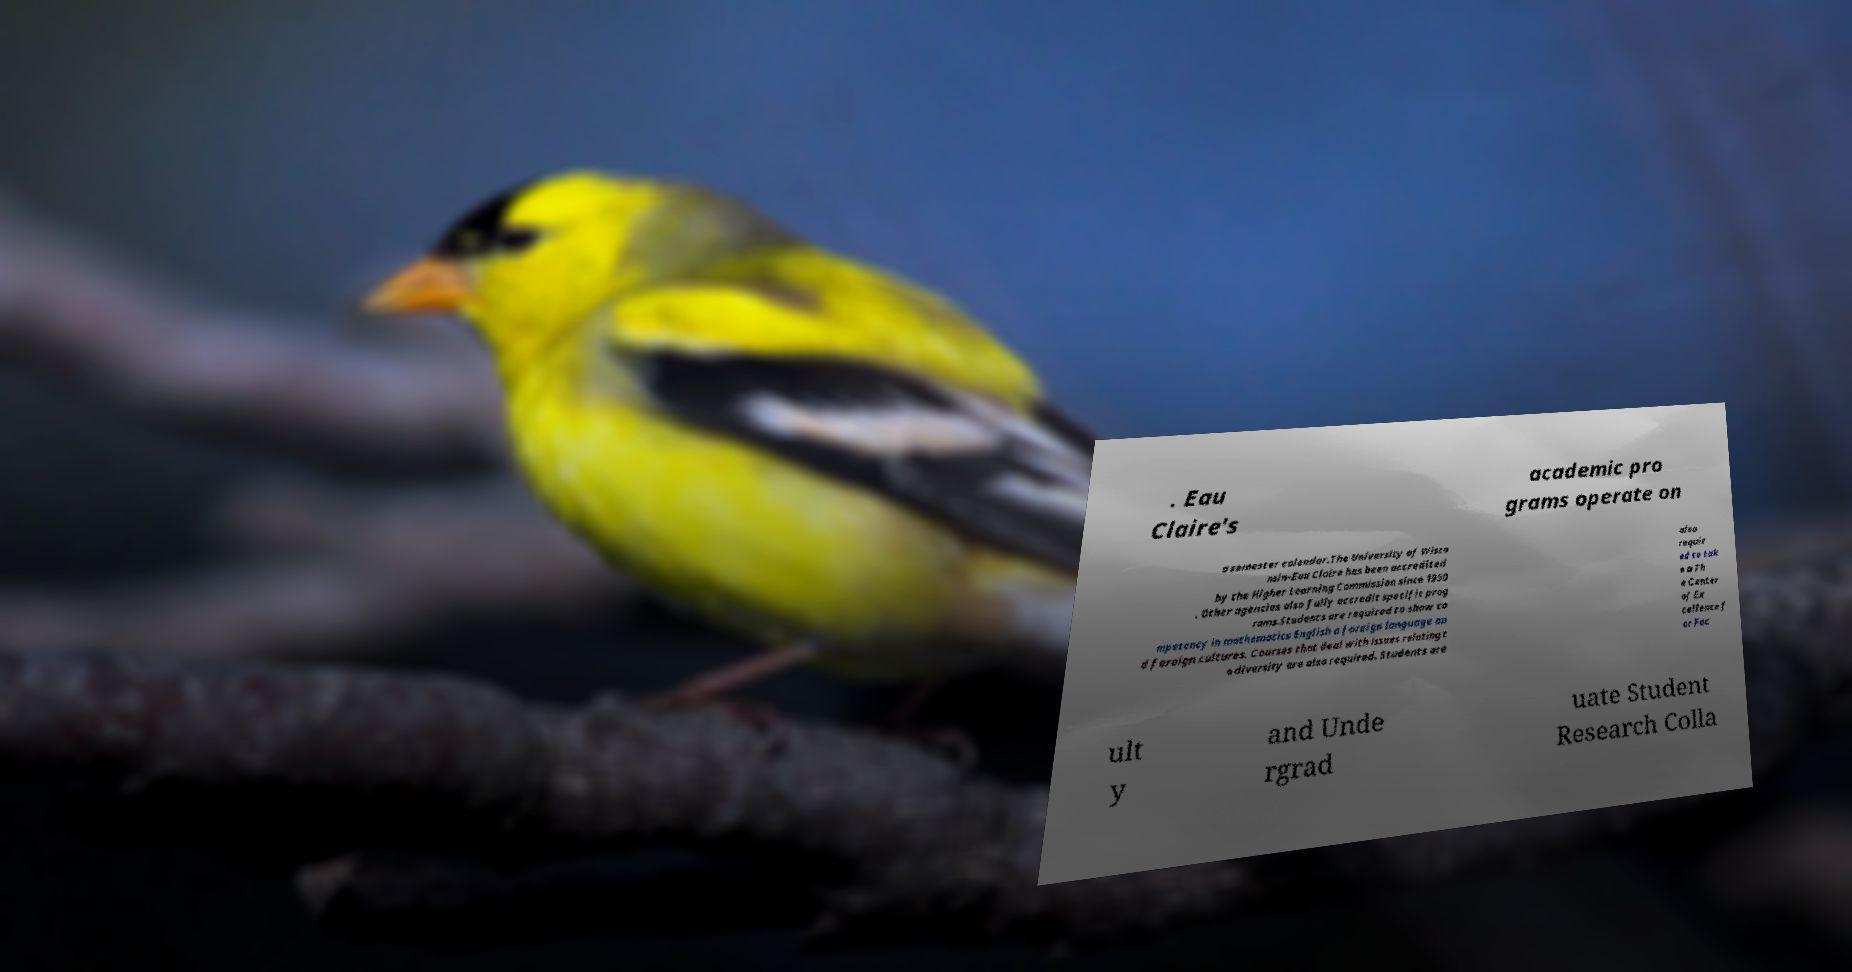For documentation purposes, I need the text within this image transcribed. Could you provide that? . Eau Claire's academic pro grams operate on a semester calendar.The University of Wisco nsin–Eau Claire has been accredited by the Higher Learning Commission since 1950 . Other agencies also fully accredit specific prog rams.Students are required to show co mpetency in mathematics English a foreign language an d foreign cultures. Courses that deal with issues relating t o diversity are also required. Students are also requir ed to tak e a Th e Center of Ex cellence f or Fac ult y and Unde rgrad uate Student Research Colla 